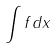<formula> <loc_0><loc_0><loc_500><loc_500>\int f d x</formula> 